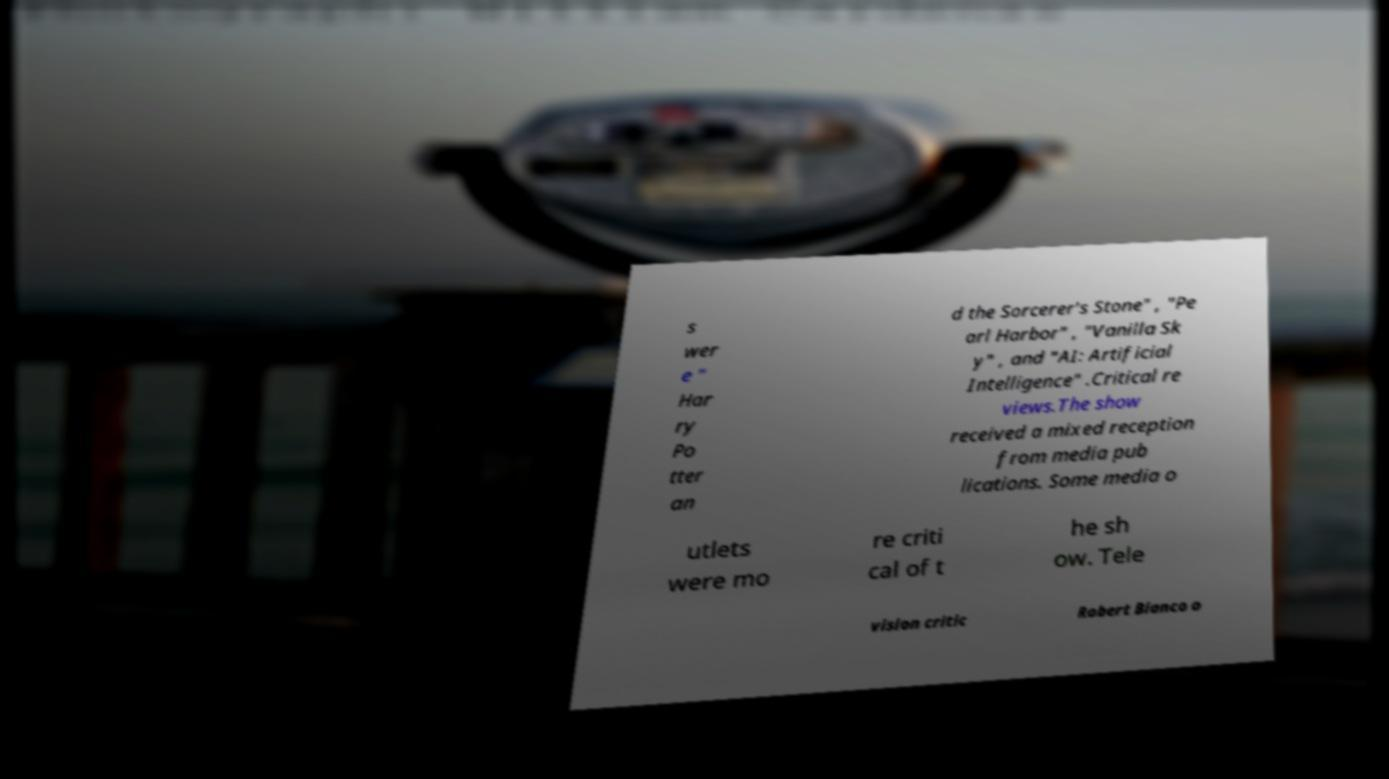Could you assist in decoding the text presented in this image and type it out clearly? s wer e " Har ry Po tter an d the Sorcerer's Stone" , "Pe arl Harbor" , "Vanilla Sk y" , and "AI: Artificial Intelligence" .Critical re views.The show received a mixed reception from media pub lications. Some media o utlets were mo re criti cal of t he sh ow. Tele vision critic Robert Bianco o 